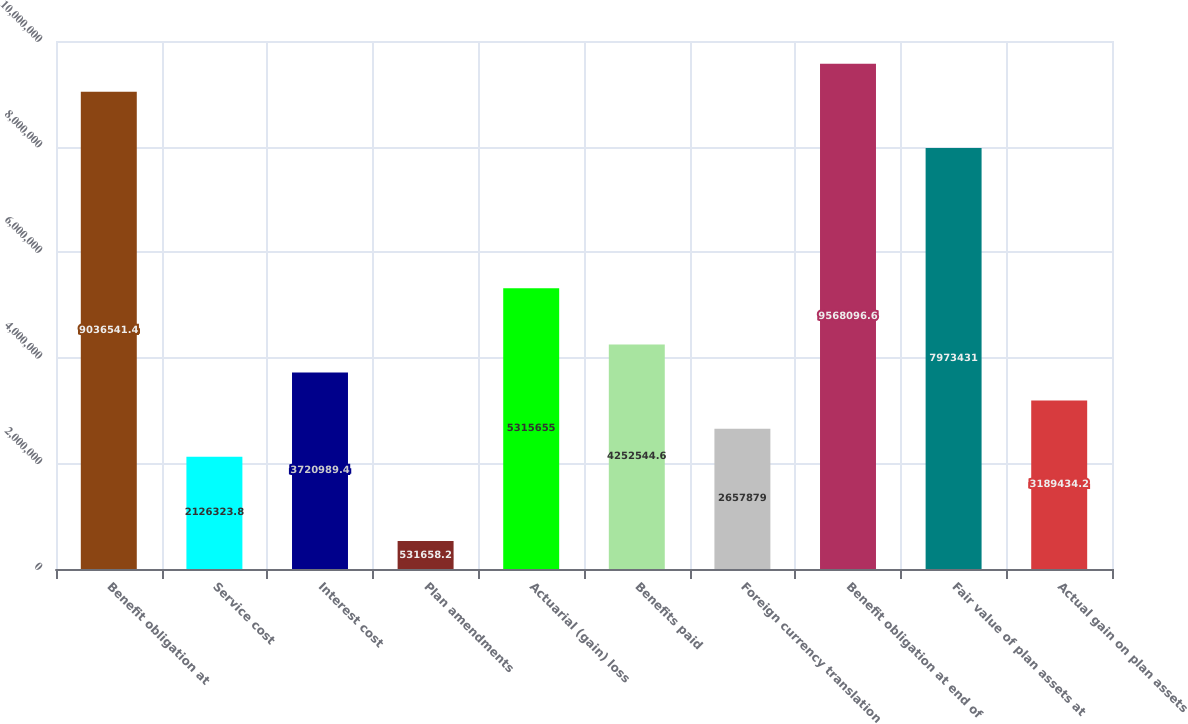Convert chart to OTSL. <chart><loc_0><loc_0><loc_500><loc_500><bar_chart><fcel>Benefit obligation at<fcel>Service cost<fcel>Interest cost<fcel>Plan amendments<fcel>Actuarial (gain) loss<fcel>Benefits paid<fcel>Foreign currency translation<fcel>Benefit obligation at end of<fcel>Fair value of plan assets at<fcel>Actual gain on plan assets<nl><fcel>9.03654e+06<fcel>2.12632e+06<fcel>3.72099e+06<fcel>531658<fcel>5.31566e+06<fcel>4.25254e+06<fcel>2.65788e+06<fcel>9.5681e+06<fcel>7.97343e+06<fcel>3.18943e+06<nl></chart> 